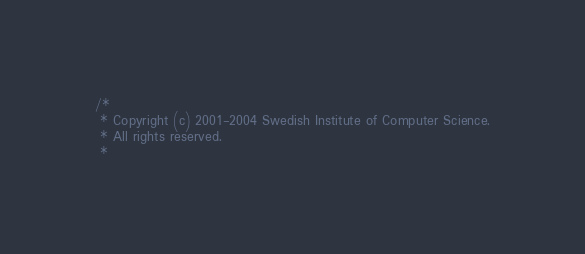<code> <loc_0><loc_0><loc_500><loc_500><_C_>/*
 * Copyright (c) 2001-2004 Swedish Institute of Computer Science.
 * All rights reserved.
 *</code> 